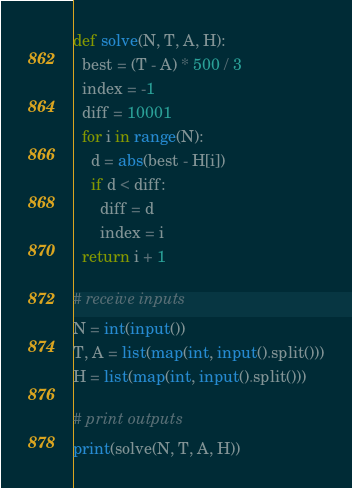Convert code to text. <code><loc_0><loc_0><loc_500><loc_500><_Python_>def solve(N, T, A, H):
  best = (T - A) * 500 / 3
  index = -1
  diff = 10001
  for i in range(N):
    d = abs(best - H[i])
    if d < diff:
      diff = d
      index = i
  return i + 1

# receive inputs
N = int(input())
T, A = list(map(int, input().split()))
H = list(map(int, input().split()))

# print outputs
print(solve(N, T, A, H))
</code> 